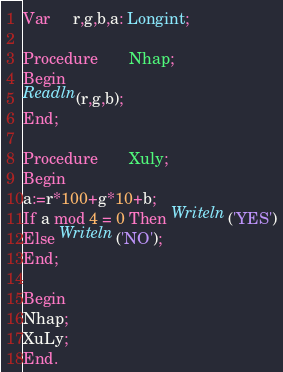Convert code to text. <code><loc_0><loc_0><loc_500><loc_500><_Pascal_>Var     r,g,b,a: Longint;

Procedure       Nhap;
Begin
Readln(r,g,b);
End;

Procedure       Xuly;
Begin
a:=r*100+g*10+b;
If a mod 4 = 0 Then Writeln('YES')
Else Writeln('NO');
End;

Begin
Nhap;
XuLy;
End.</code> 